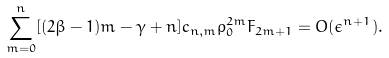Convert formula to latex. <formula><loc_0><loc_0><loc_500><loc_500>\sum _ { m = 0 } ^ { n } [ ( 2 \beta - 1 ) m - \gamma + n ] c _ { n , m } \rho _ { 0 } ^ { 2 m } F _ { 2 m + 1 } = O ( \epsilon ^ { n + 1 } ) .</formula> 